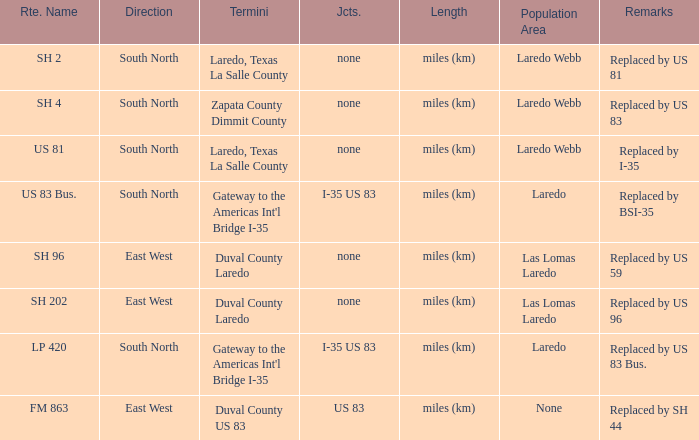How many junctions have "replaced by bsi-35" listed in their remarks section? 1.0. Can you give me this table as a dict? {'header': ['Rte. Name', 'Direction', 'Termini', 'Jcts.', 'Length', 'Population Area', 'Remarks'], 'rows': [['SH 2', 'South North', 'Laredo, Texas La Salle County', 'none', 'miles (km)', 'Laredo Webb', 'Replaced by US 81'], ['SH 4', 'South North', 'Zapata County Dimmit County', 'none', 'miles (km)', 'Laredo Webb', 'Replaced by US 83'], ['US 81', 'South North', 'Laredo, Texas La Salle County', 'none', 'miles (km)', 'Laredo Webb', 'Replaced by I-35'], ['US 83 Bus.', 'South North', "Gateway to the Americas Int'l Bridge I-35", 'I-35 US 83', 'miles (km)', 'Laredo', 'Replaced by BSI-35'], ['SH 96', 'East West', 'Duval County Laredo', 'none', 'miles (km)', 'Las Lomas Laredo', 'Replaced by US 59'], ['SH 202', 'East West', 'Duval County Laredo', 'none', 'miles (km)', 'Las Lomas Laredo', 'Replaced by US 96'], ['LP 420', 'South North', "Gateway to the Americas Int'l Bridge I-35", 'I-35 US 83', 'miles (km)', 'Laredo', 'Replaced by US 83 Bus.'], ['FM 863', 'East West', 'Duval County US 83', 'US 83', 'miles (km)', 'None', 'Replaced by SH 44']]} 